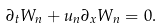Convert formula to latex. <formula><loc_0><loc_0><loc_500><loc_500>\partial _ { t } W _ { n } + u _ { n } \partial _ { x } W _ { n } = 0 .</formula> 